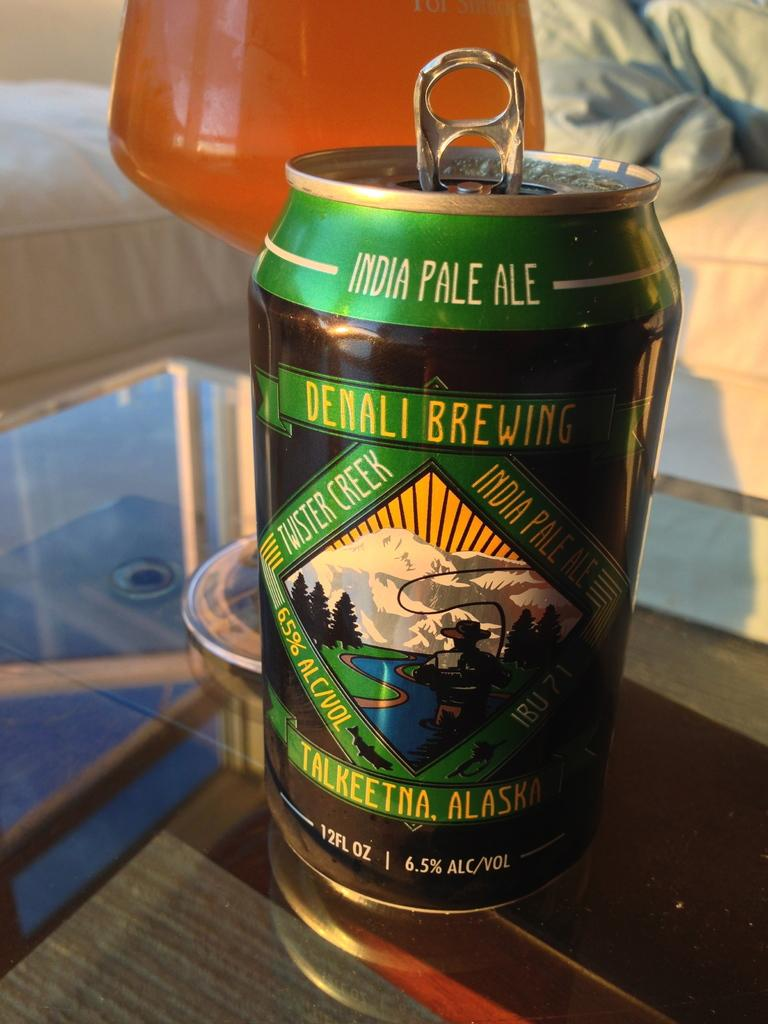<image>
Write a terse but informative summary of the picture. a can that has the word India at the top 